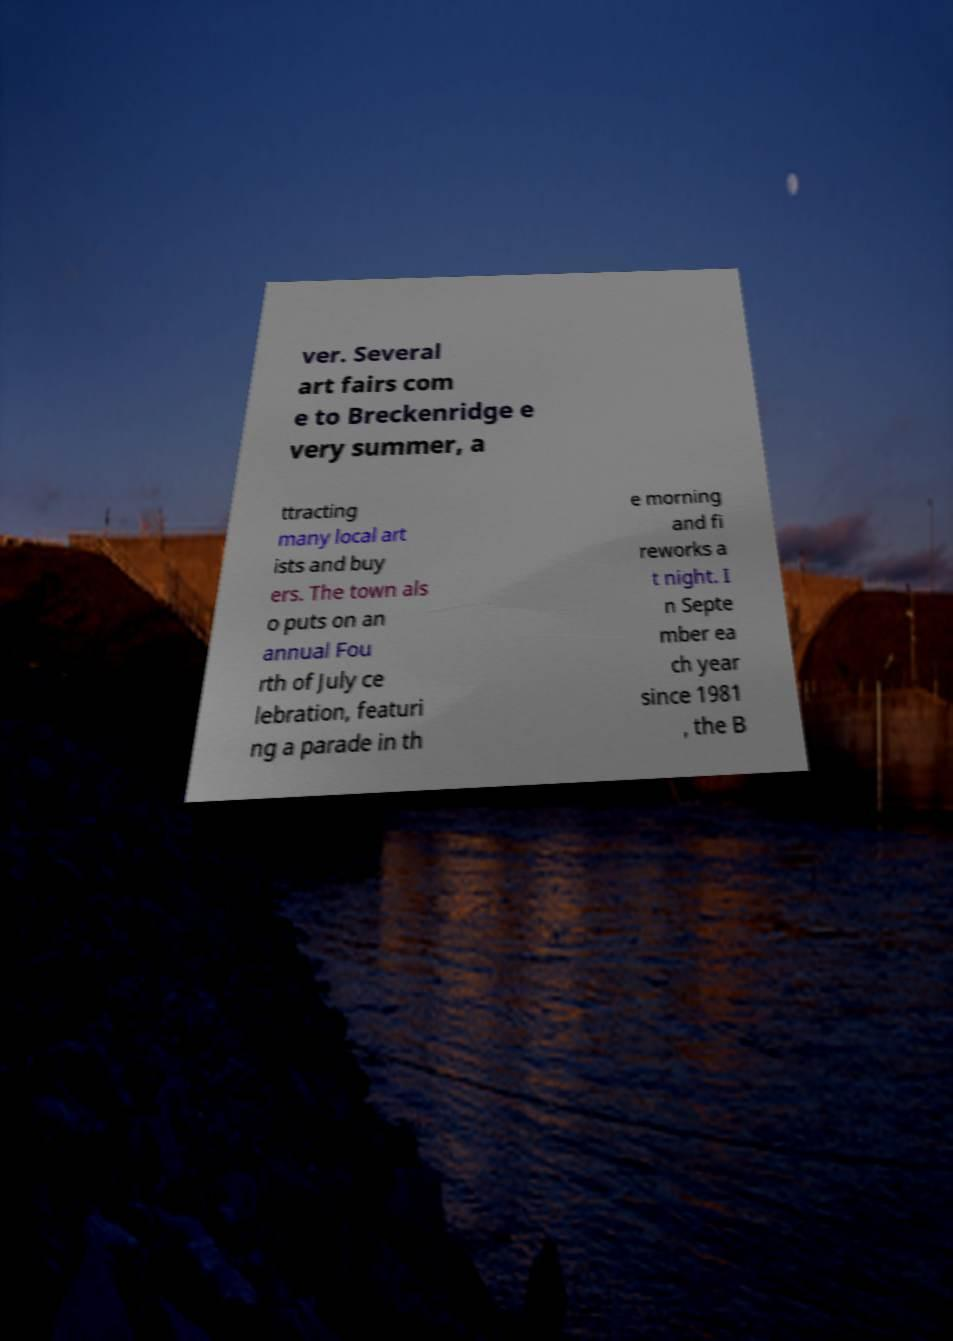For documentation purposes, I need the text within this image transcribed. Could you provide that? ver. Several art fairs com e to Breckenridge e very summer, a ttracting many local art ists and buy ers. The town als o puts on an annual Fou rth of July ce lebration, featuri ng a parade in th e morning and fi reworks a t night. I n Septe mber ea ch year since 1981 , the B 